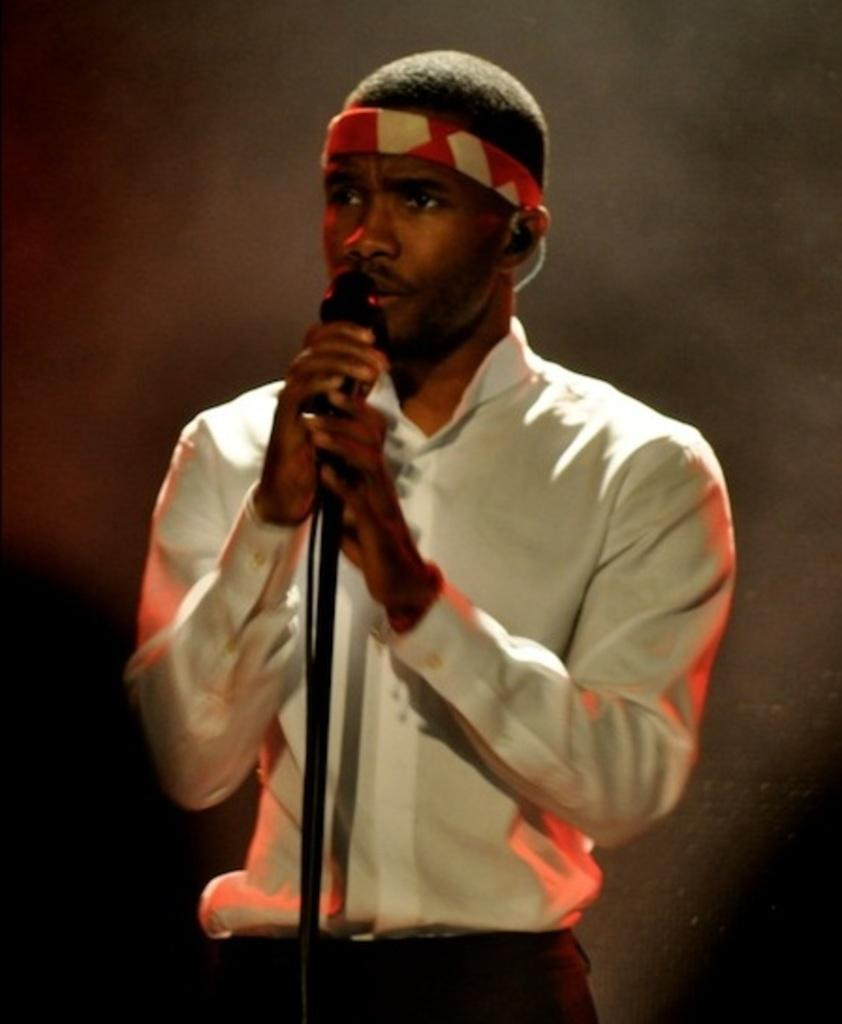What is the main subject of the image? The main subject of the image is a man. What is the man doing in the image? The man is standing in the image. What object is the man holding in the image? The man is holding a microphone in the image. What color is the shirt the man is wearing? The man is wearing a white color shirt in the image. What is present in front of the man? There is a mic stand in front of the man in the image. What is the man wearing on his head? The man is wearing headgear in the image. How many bees can be seen buzzing around the man in the image? There are no bees present in the image; the man is holding a microphone and standing near a mic stand. 